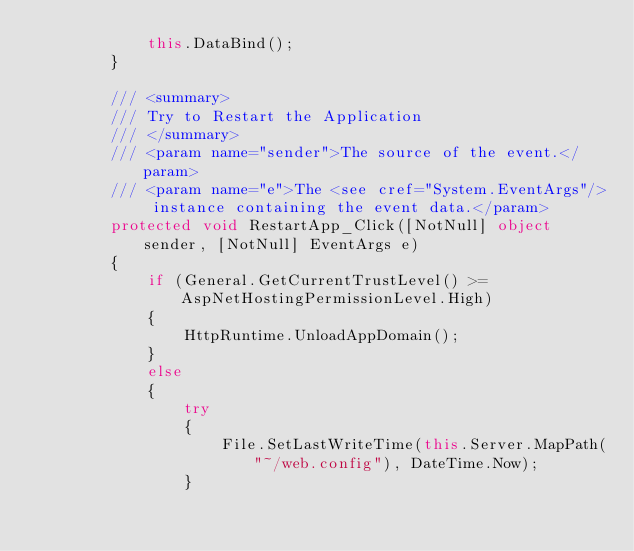Convert code to text. <code><loc_0><loc_0><loc_500><loc_500><_C#_>            this.DataBind();
        }

        /// <summary>
        /// Try to Restart the Application
        /// </summary>
        /// <param name="sender">The source of the event.</param>
        /// <param name="e">The <see cref="System.EventArgs"/> instance containing the event data.</param>
        protected void RestartApp_Click([NotNull] object sender, [NotNull] EventArgs e)
        {
            if (General.GetCurrentTrustLevel() >= AspNetHostingPermissionLevel.High)
            {
                HttpRuntime.UnloadAppDomain();
            }
            else
            {
                try
                {
                    File.SetLastWriteTime(this.Server.MapPath("~/web.config"), DateTime.Now);
                }</code> 